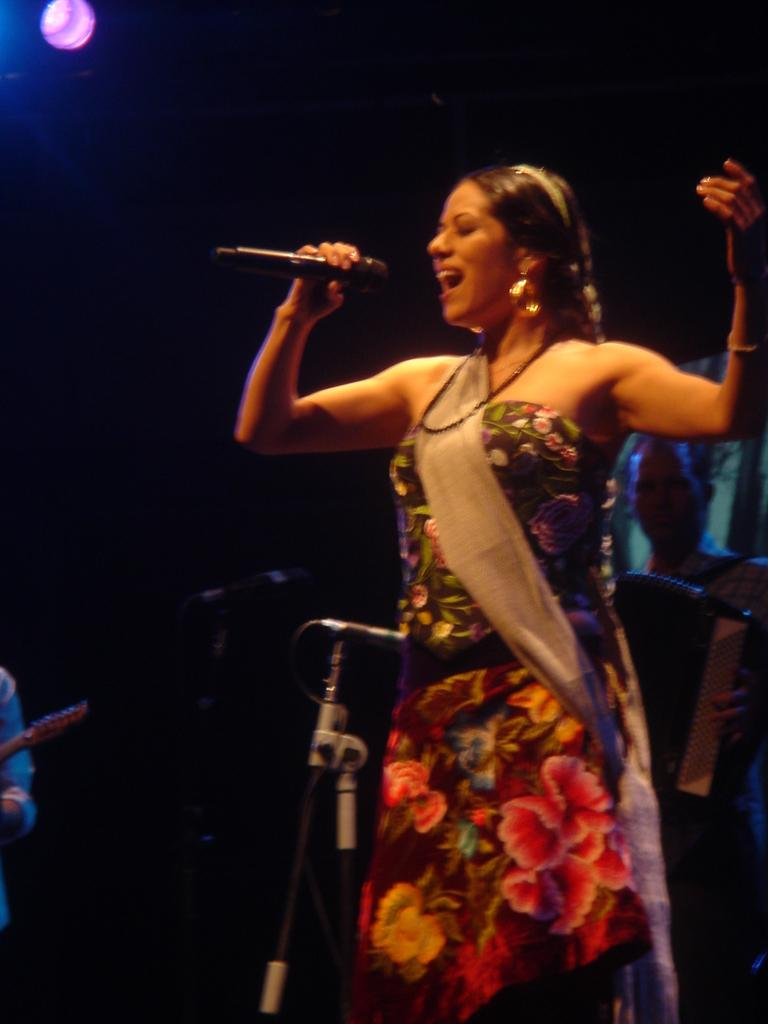Who is the main subject in the image? There is a woman in the image. What is the woman holding in the image? The woman is holding a microphone. What is the woman doing in the image? The woman is singing. How many microphones with stands are visible in the image? There are two microphones with stands in the image. What can be seen in the background of the image? There are people in the background of the image. What type of theory is the beggar discussing with the egg in the image? There is no beggar, egg, or discussion of a theory present in the image. 